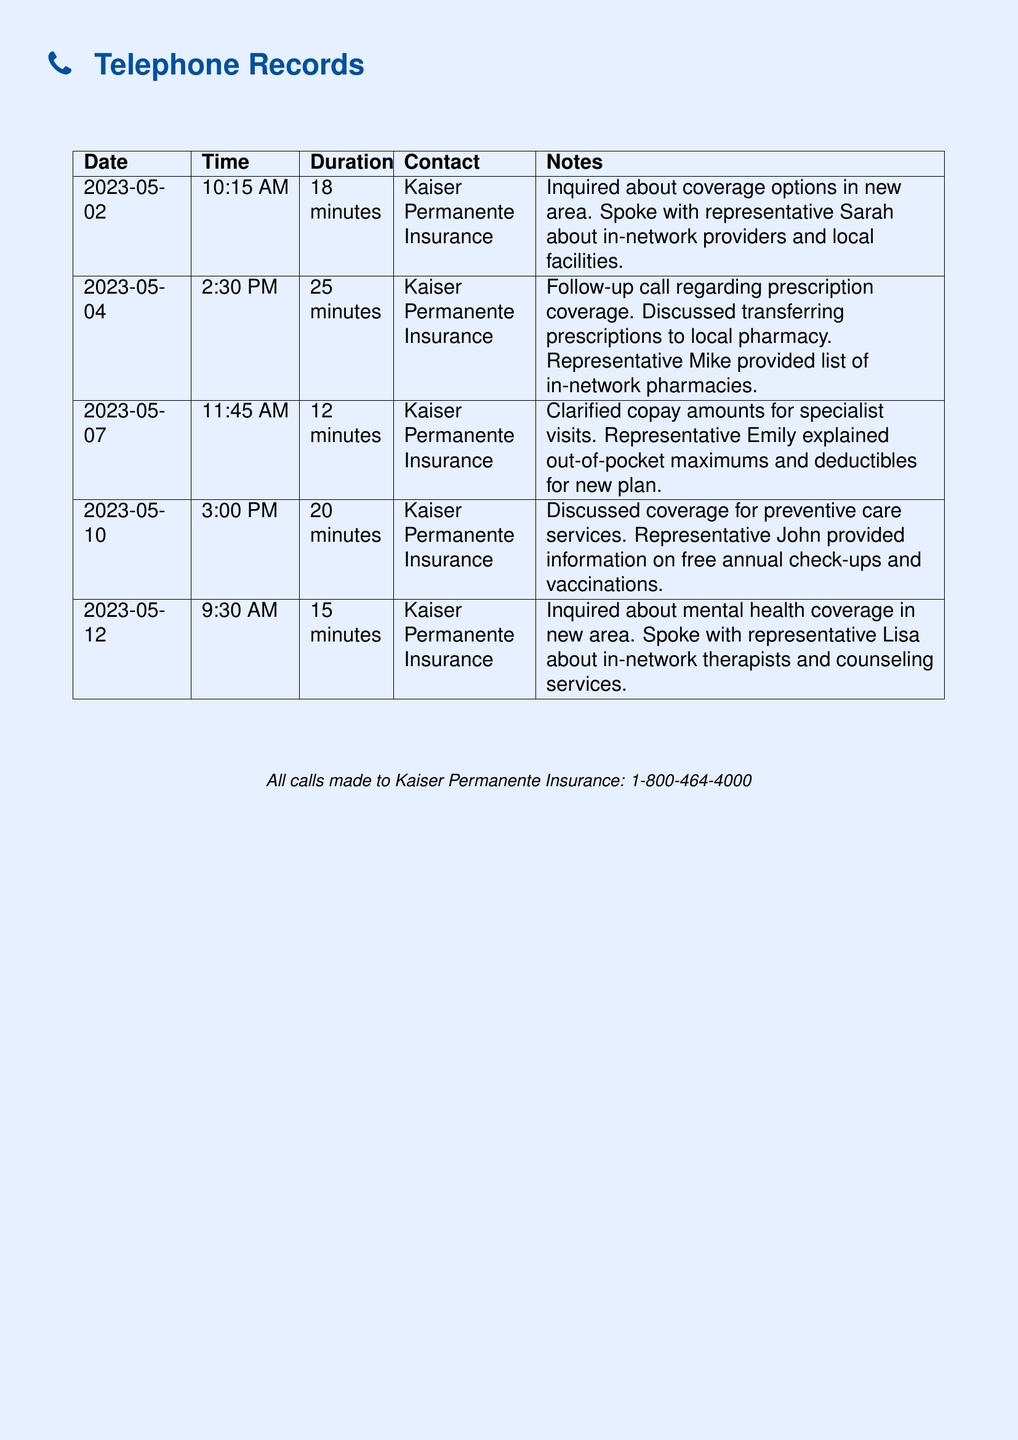what date was the first call made? The first call was made on 2023-05-02, as indicated in the document.
Answer: 2023-05-02 how long was the duration of the call on 2023-05-04? The duration of the call made on 2023-05-04 was 25 minutes, as shown in the document.
Answer: 25 minutes who did the caller speak with on the last noted call? On the last noted call, the caller spoke with representative Lisa, as recorded in the notes.
Answer: Lisa what information was discussed in the call on 2023-05-10? The information discussed during the call on 2023-05-10 was coverage for preventive care services, outlined in the notes section.
Answer: preventive care services how many calls were made to Kaiser Permanente Insurance? The document lists a total of five calls made to Kaiser Permanente Insurance, as indicated by the number of entries in the table.
Answer: five what was the primary topic of the call on 2023-05-12? The primary topic of the call on 2023-05-12 was mental health coverage, as mentioned in the notes.
Answer: mental health coverage who explained copay amounts during the call on 2023-05-07? Representative Emily explained copay amounts during the call on 2023-05-07, as detailed in the document.
Answer: Emily what was discussed in the second call on 2023-05-04? In the second call on 2023-05-04, the discussion centered around prescription coverage, as reflected in the notes.
Answer: prescription coverage 